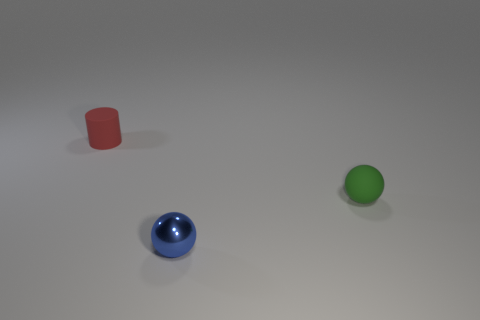How many other green matte spheres are the same size as the green rubber sphere? There are no other spheres in the image that match the size and material of the green matte sphere. 